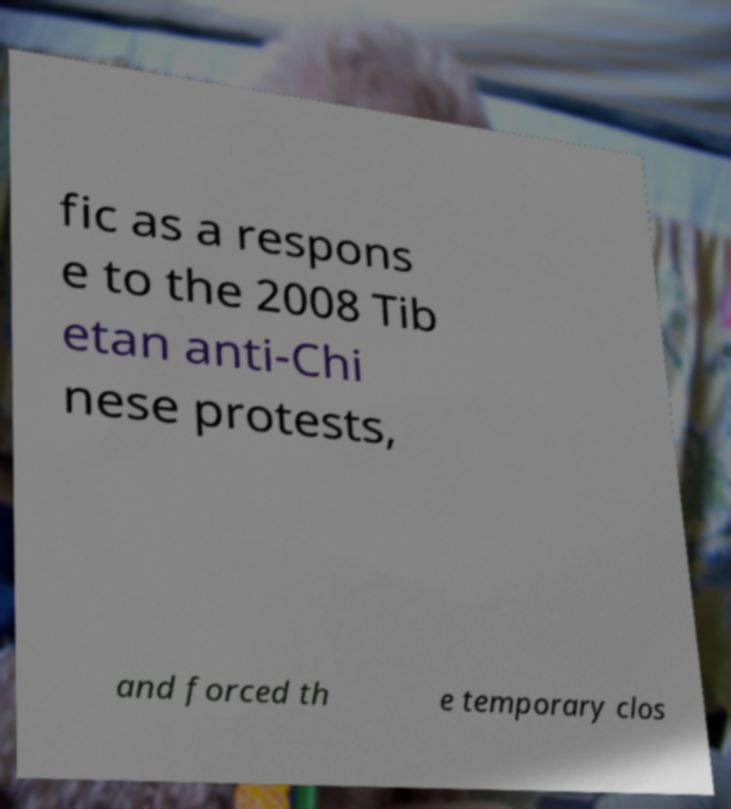Please read and relay the text visible in this image. What does it say? fic as a respons e to the 2008 Tib etan anti-Chi nese protests, and forced th e temporary clos 